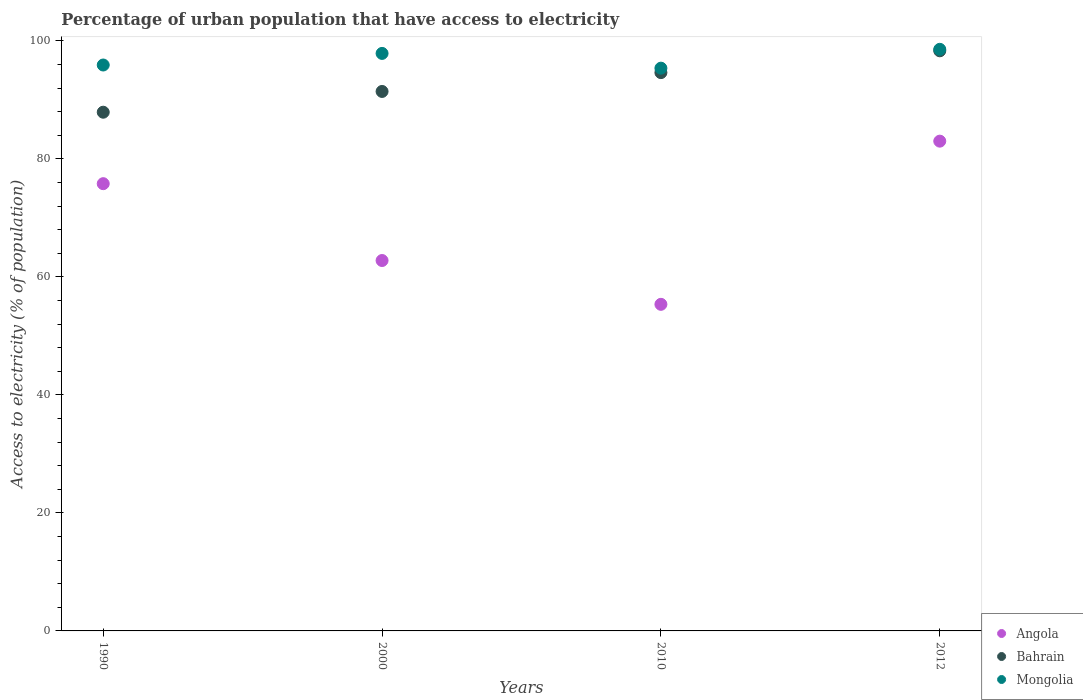How many different coloured dotlines are there?
Ensure brevity in your answer.  3. Is the number of dotlines equal to the number of legend labels?
Provide a succinct answer. Yes. What is the percentage of urban population that have access to electricity in Mongolia in 2012?
Your answer should be compact. 98.56. Across all years, what is the maximum percentage of urban population that have access to electricity in Bahrain?
Your response must be concise. 98.31. Across all years, what is the minimum percentage of urban population that have access to electricity in Mongolia?
Offer a very short reply. 95.37. In which year was the percentage of urban population that have access to electricity in Mongolia minimum?
Keep it short and to the point. 2010. What is the total percentage of urban population that have access to electricity in Angola in the graph?
Make the answer very short. 276.91. What is the difference between the percentage of urban population that have access to electricity in Bahrain in 1990 and that in 2000?
Give a very brief answer. -3.52. What is the difference between the percentage of urban population that have access to electricity in Bahrain in 2000 and the percentage of urban population that have access to electricity in Mongolia in 2012?
Give a very brief answer. -7.14. What is the average percentage of urban population that have access to electricity in Angola per year?
Ensure brevity in your answer.  69.23. In the year 2012, what is the difference between the percentage of urban population that have access to electricity in Angola and percentage of urban population that have access to electricity in Bahrain?
Your answer should be very brief. -15.31. In how many years, is the percentage of urban population that have access to electricity in Bahrain greater than 32 %?
Make the answer very short. 4. What is the ratio of the percentage of urban population that have access to electricity in Angola in 2000 to that in 2010?
Keep it short and to the point. 1.13. Is the percentage of urban population that have access to electricity in Angola in 2010 less than that in 2012?
Provide a short and direct response. Yes. What is the difference between the highest and the second highest percentage of urban population that have access to electricity in Angola?
Your answer should be very brief. 7.21. What is the difference between the highest and the lowest percentage of urban population that have access to electricity in Bahrain?
Offer a terse response. 10.41. Is the sum of the percentage of urban population that have access to electricity in Angola in 2000 and 2010 greater than the maximum percentage of urban population that have access to electricity in Bahrain across all years?
Offer a terse response. Yes. Is it the case that in every year, the sum of the percentage of urban population that have access to electricity in Bahrain and percentage of urban population that have access to electricity in Angola  is greater than the percentage of urban population that have access to electricity in Mongolia?
Give a very brief answer. Yes. Does the percentage of urban population that have access to electricity in Bahrain monotonically increase over the years?
Your answer should be compact. Yes. How many dotlines are there?
Keep it short and to the point. 3. How many years are there in the graph?
Give a very brief answer. 4. Are the values on the major ticks of Y-axis written in scientific E-notation?
Keep it short and to the point. No. Where does the legend appear in the graph?
Provide a succinct answer. Bottom right. How are the legend labels stacked?
Your response must be concise. Vertical. What is the title of the graph?
Your answer should be compact. Percentage of urban population that have access to electricity. Does "Angola" appear as one of the legend labels in the graph?
Offer a terse response. Yes. What is the label or title of the X-axis?
Your answer should be very brief. Years. What is the label or title of the Y-axis?
Provide a succinct answer. Access to electricity (% of population). What is the Access to electricity (% of population) of Angola in 1990?
Provide a succinct answer. 75.79. What is the Access to electricity (% of population) in Bahrain in 1990?
Give a very brief answer. 87.9. What is the Access to electricity (% of population) in Mongolia in 1990?
Give a very brief answer. 95.9. What is the Access to electricity (% of population) of Angola in 2000?
Your answer should be compact. 62.77. What is the Access to electricity (% of population) of Bahrain in 2000?
Your response must be concise. 91.42. What is the Access to electricity (% of population) in Mongolia in 2000?
Ensure brevity in your answer.  97.87. What is the Access to electricity (% of population) of Angola in 2010?
Offer a very short reply. 55.35. What is the Access to electricity (% of population) in Bahrain in 2010?
Your answer should be compact. 94.61. What is the Access to electricity (% of population) of Mongolia in 2010?
Your answer should be compact. 95.37. What is the Access to electricity (% of population) in Bahrain in 2012?
Provide a short and direct response. 98.31. What is the Access to electricity (% of population) in Mongolia in 2012?
Your answer should be compact. 98.56. Across all years, what is the maximum Access to electricity (% of population) of Bahrain?
Your response must be concise. 98.31. Across all years, what is the maximum Access to electricity (% of population) of Mongolia?
Your answer should be compact. 98.56. Across all years, what is the minimum Access to electricity (% of population) in Angola?
Give a very brief answer. 55.35. Across all years, what is the minimum Access to electricity (% of population) in Bahrain?
Offer a very short reply. 87.9. Across all years, what is the minimum Access to electricity (% of population) of Mongolia?
Your answer should be compact. 95.37. What is the total Access to electricity (% of population) of Angola in the graph?
Offer a terse response. 276.91. What is the total Access to electricity (% of population) of Bahrain in the graph?
Provide a short and direct response. 372.25. What is the total Access to electricity (% of population) in Mongolia in the graph?
Offer a terse response. 387.7. What is the difference between the Access to electricity (% of population) in Angola in 1990 and that in 2000?
Offer a terse response. 13.02. What is the difference between the Access to electricity (% of population) in Bahrain in 1990 and that in 2000?
Keep it short and to the point. -3.52. What is the difference between the Access to electricity (% of population) of Mongolia in 1990 and that in 2000?
Your answer should be compact. -1.96. What is the difference between the Access to electricity (% of population) in Angola in 1990 and that in 2010?
Your answer should be very brief. 20.45. What is the difference between the Access to electricity (% of population) of Bahrain in 1990 and that in 2010?
Your response must be concise. -6.71. What is the difference between the Access to electricity (% of population) of Mongolia in 1990 and that in 2010?
Provide a succinct answer. 0.54. What is the difference between the Access to electricity (% of population) in Angola in 1990 and that in 2012?
Provide a succinct answer. -7.21. What is the difference between the Access to electricity (% of population) in Bahrain in 1990 and that in 2012?
Offer a terse response. -10.41. What is the difference between the Access to electricity (% of population) in Mongolia in 1990 and that in 2012?
Ensure brevity in your answer.  -2.66. What is the difference between the Access to electricity (% of population) of Angola in 2000 and that in 2010?
Provide a short and direct response. 7.42. What is the difference between the Access to electricity (% of population) in Bahrain in 2000 and that in 2010?
Provide a succinct answer. -3.19. What is the difference between the Access to electricity (% of population) in Mongolia in 2000 and that in 2010?
Provide a short and direct response. 2.5. What is the difference between the Access to electricity (% of population) of Angola in 2000 and that in 2012?
Your response must be concise. -20.23. What is the difference between the Access to electricity (% of population) in Bahrain in 2000 and that in 2012?
Ensure brevity in your answer.  -6.89. What is the difference between the Access to electricity (% of population) in Mongolia in 2000 and that in 2012?
Offer a terse response. -0.69. What is the difference between the Access to electricity (% of population) in Angola in 2010 and that in 2012?
Offer a terse response. -27.65. What is the difference between the Access to electricity (% of population) of Bahrain in 2010 and that in 2012?
Offer a very short reply. -3.7. What is the difference between the Access to electricity (% of population) in Mongolia in 2010 and that in 2012?
Provide a short and direct response. -3.19. What is the difference between the Access to electricity (% of population) in Angola in 1990 and the Access to electricity (% of population) in Bahrain in 2000?
Ensure brevity in your answer.  -15.63. What is the difference between the Access to electricity (% of population) in Angola in 1990 and the Access to electricity (% of population) in Mongolia in 2000?
Provide a short and direct response. -22.07. What is the difference between the Access to electricity (% of population) of Bahrain in 1990 and the Access to electricity (% of population) of Mongolia in 2000?
Make the answer very short. -9.96. What is the difference between the Access to electricity (% of population) in Angola in 1990 and the Access to electricity (% of population) in Bahrain in 2010?
Your answer should be compact. -18.82. What is the difference between the Access to electricity (% of population) of Angola in 1990 and the Access to electricity (% of population) of Mongolia in 2010?
Give a very brief answer. -19.57. What is the difference between the Access to electricity (% of population) in Bahrain in 1990 and the Access to electricity (% of population) in Mongolia in 2010?
Ensure brevity in your answer.  -7.46. What is the difference between the Access to electricity (% of population) of Angola in 1990 and the Access to electricity (% of population) of Bahrain in 2012?
Ensure brevity in your answer.  -22.52. What is the difference between the Access to electricity (% of population) of Angola in 1990 and the Access to electricity (% of population) of Mongolia in 2012?
Give a very brief answer. -22.77. What is the difference between the Access to electricity (% of population) of Bahrain in 1990 and the Access to electricity (% of population) of Mongolia in 2012?
Make the answer very short. -10.66. What is the difference between the Access to electricity (% of population) of Angola in 2000 and the Access to electricity (% of population) of Bahrain in 2010?
Your response must be concise. -31.84. What is the difference between the Access to electricity (% of population) of Angola in 2000 and the Access to electricity (% of population) of Mongolia in 2010?
Ensure brevity in your answer.  -32.6. What is the difference between the Access to electricity (% of population) in Bahrain in 2000 and the Access to electricity (% of population) in Mongolia in 2010?
Your answer should be very brief. -3.95. What is the difference between the Access to electricity (% of population) in Angola in 2000 and the Access to electricity (% of population) in Bahrain in 2012?
Ensure brevity in your answer.  -35.54. What is the difference between the Access to electricity (% of population) in Angola in 2000 and the Access to electricity (% of population) in Mongolia in 2012?
Your response must be concise. -35.79. What is the difference between the Access to electricity (% of population) of Bahrain in 2000 and the Access to electricity (% of population) of Mongolia in 2012?
Your response must be concise. -7.14. What is the difference between the Access to electricity (% of population) of Angola in 2010 and the Access to electricity (% of population) of Bahrain in 2012?
Your response must be concise. -42.96. What is the difference between the Access to electricity (% of population) of Angola in 2010 and the Access to electricity (% of population) of Mongolia in 2012?
Your answer should be compact. -43.21. What is the difference between the Access to electricity (% of population) of Bahrain in 2010 and the Access to electricity (% of population) of Mongolia in 2012?
Offer a terse response. -3.95. What is the average Access to electricity (% of population) in Angola per year?
Make the answer very short. 69.23. What is the average Access to electricity (% of population) of Bahrain per year?
Make the answer very short. 93.06. What is the average Access to electricity (% of population) in Mongolia per year?
Your answer should be very brief. 96.93. In the year 1990, what is the difference between the Access to electricity (% of population) in Angola and Access to electricity (% of population) in Bahrain?
Provide a short and direct response. -12.11. In the year 1990, what is the difference between the Access to electricity (% of population) of Angola and Access to electricity (% of population) of Mongolia?
Your answer should be compact. -20.11. In the year 1990, what is the difference between the Access to electricity (% of population) in Bahrain and Access to electricity (% of population) in Mongolia?
Give a very brief answer. -8. In the year 2000, what is the difference between the Access to electricity (% of population) of Angola and Access to electricity (% of population) of Bahrain?
Make the answer very short. -28.65. In the year 2000, what is the difference between the Access to electricity (% of population) in Angola and Access to electricity (% of population) in Mongolia?
Your answer should be compact. -35.1. In the year 2000, what is the difference between the Access to electricity (% of population) of Bahrain and Access to electricity (% of population) of Mongolia?
Give a very brief answer. -6.45. In the year 2010, what is the difference between the Access to electricity (% of population) in Angola and Access to electricity (% of population) in Bahrain?
Offer a very short reply. -39.27. In the year 2010, what is the difference between the Access to electricity (% of population) of Angola and Access to electricity (% of population) of Mongolia?
Your answer should be very brief. -40.02. In the year 2010, what is the difference between the Access to electricity (% of population) in Bahrain and Access to electricity (% of population) in Mongolia?
Your response must be concise. -0.75. In the year 2012, what is the difference between the Access to electricity (% of population) in Angola and Access to electricity (% of population) in Bahrain?
Provide a short and direct response. -15.31. In the year 2012, what is the difference between the Access to electricity (% of population) in Angola and Access to electricity (% of population) in Mongolia?
Your response must be concise. -15.56. What is the ratio of the Access to electricity (% of population) of Angola in 1990 to that in 2000?
Your response must be concise. 1.21. What is the ratio of the Access to electricity (% of population) in Bahrain in 1990 to that in 2000?
Provide a short and direct response. 0.96. What is the ratio of the Access to electricity (% of population) of Mongolia in 1990 to that in 2000?
Offer a terse response. 0.98. What is the ratio of the Access to electricity (% of population) in Angola in 1990 to that in 2010?
Give a very brief answer. 1.37. What is the ratio of the Access to electricity (% of population) in Bahrain in 1990 to that in 2010?
Your answer should be compact. 0.93. What is the ratio of the Access to electricity (% of population) of Mongolia in 1990 to that in 2010?
Offer a very short reply. 1.01. What is the ratio of the Access to electricity (% of population) of Angola in 1990 to that in 2012?
Your answer should be compact. 0.91. What is the ratio of the Access to electricity (% of population) in Bahrain in 1990 to that in 2012?
Provide a succinct answer. 0.89. What is the ratio of the Access to electricity (% of population) of Angola in 2000 to that in 2010?
Your response must be concise. 1.13. What is the ratio of the Access to electricity (% of population) in Bahrain in 2000 to that in 2010?
Ensure brevity in your answer.  0.97. What is the ratio of the Access to electricity (% of population) in Mongolia in 2000 to that in 2010?
Your answer should be very brief. 1.03. What is the ratio of the Access to electricity (% of population) in Angola in 2000 to that in 2012?
Your answer should be very brief. 0.76. What is the ratio of the Access to electricity (% of population) in Bahrain in 2000 to that in 2012?
Give a very brief answer. 0.93. What is the ratio of the Access to electricity (% of population) of Angola in 2010 to that in 2012?
Your answer should be compact. 0.67. What is the ratio of the Access to electricity (% of population) in Bahrain in 2010 to that in 2012?
Your answer should be very brief. 0.96. What is the ratio of the Access to electricity (% of population) of Mongolia in 2010 to that in 2012?
Your response must be concise. 0.97. What is the difference between the highest and the second highest Access to electricity (% of population) in Angola?
Ensure brevity in your answer.  7.21. What is the difference between the highest and the second highest Access to electricity (% of population) in Bahrain?
Provide a short and direct response. 3.7. What is the difference between the highest and the second highest Access to electricity (% of population) in Mongolia?
Your answer should be very brief. 0.69. What is the difference between the highest and the lowest Access to electricity (% of population) of Angola?
Ensure brevity in your answer.  27.65. What is the difference between the highest and the lowest Access to electricity (% of population) in Bahrain?
Make the answer very short. 10.41. What is the difference between the highest and the lowest Access to electricity (% of population) in Mongolia?
Your answer should be compact. 3.19. 